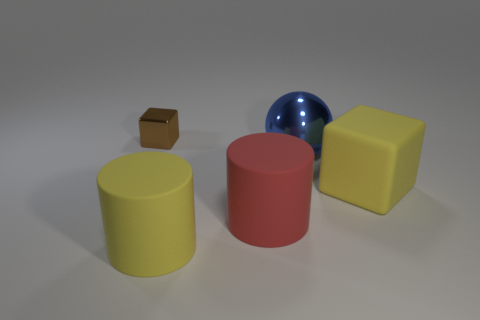Add 2 big rubber things. How many objects exist? 7 Subtract all blocks. How many objects are left? 3 Add 1 big red rubber blocks. How many big red rubber blocks exist? 1 Subtract 1 yellow cubes. How many objects are left? 4 Subtract all large things. Subtract all large cyan metallic things. How many objects are left? 1 Add 3 blue metal things. How many blue metal things are left? 4 